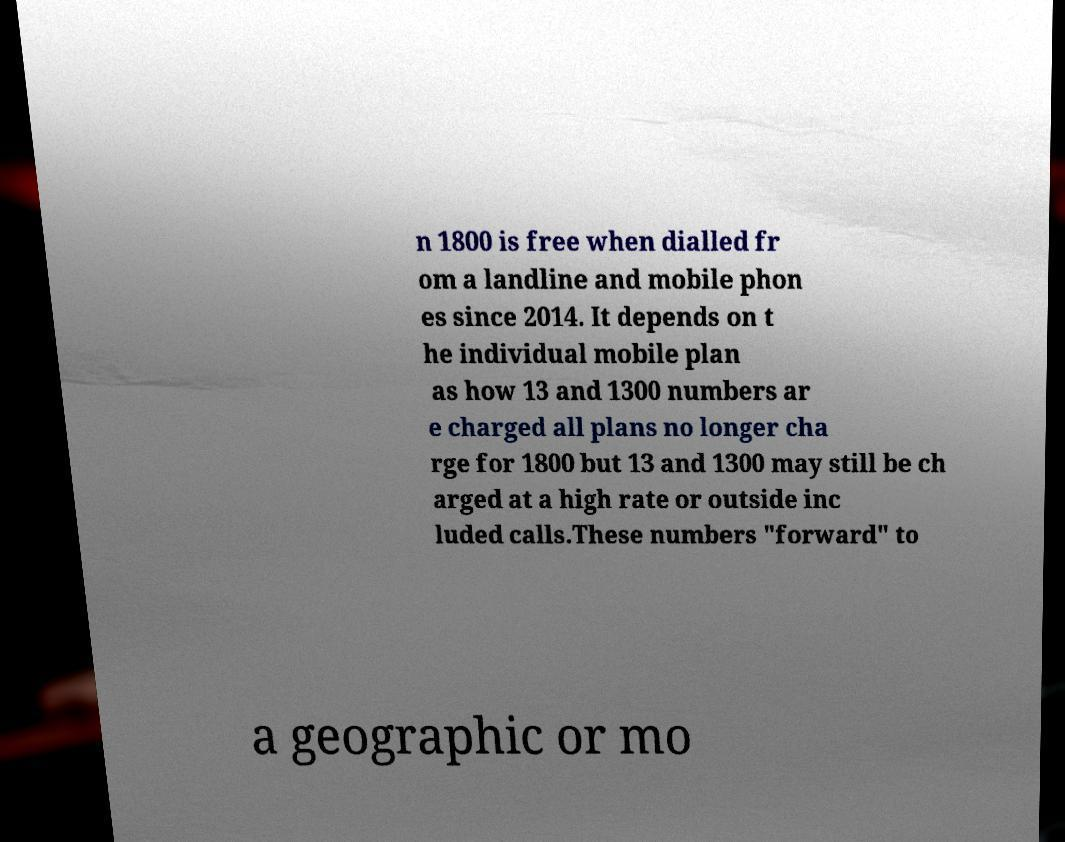Can you read and provide the text displayed in the image?This photo seems to have some interesting text. Can you extract and type it out for me? n 1800 is free when dialled fr om a landline and mobile phon es since 2014. It depends on t he individual mobile plan as how 13 and 1300 numbers ar e charged all plans no longer cha rge for 1800 but 13 and 1300 may still be ch arged at a high rate or outside inc luded calls.These numbers "forward" to a geographic or mo 